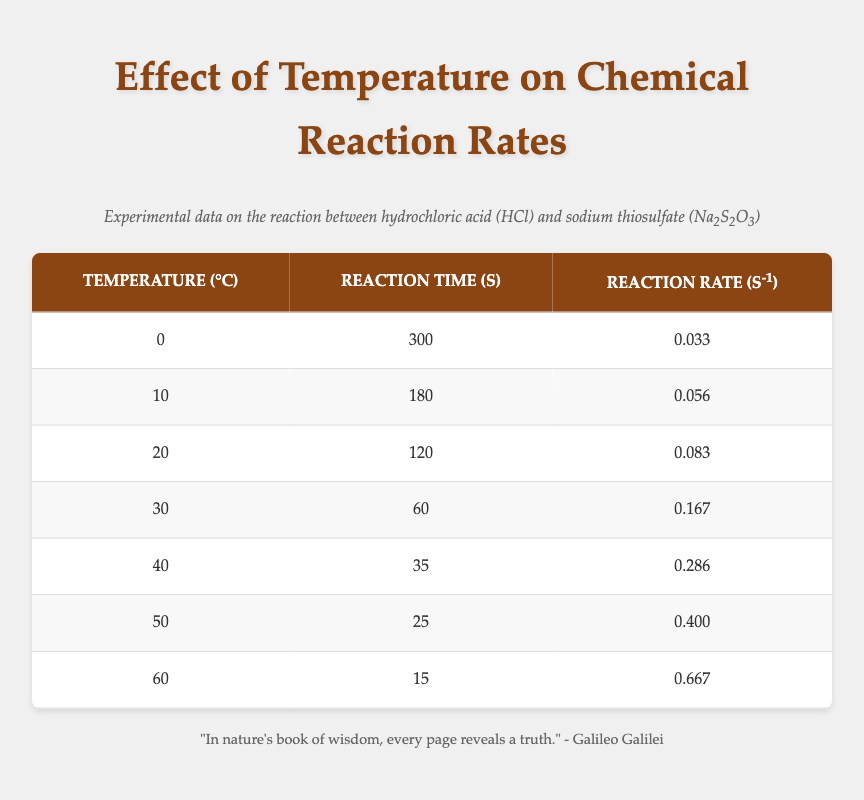What is the reaction time at 40 degrees Celsius? From the table, at 40 degrees Celsius, the reaction time is directly listed as 35 seconds.
Answer: 35 seconds What is the reaction rate at room temperature (20 degrees Celsius)? At 20 degrees Celsius, the reaction rate is provided in the table as 0.083 s^-1.
Answer: 0.083 s^-1 What is the difference in reaction time between 10 degrees Celsius and 30 degrees Celsius? The reaction time at 10 degrees Celsius is 180 seconds, and at 30 degrees Celsius, it is 60 seconds. The difference is 180 - 60 = 120 seconds.
Answer: 120 seconds Is the reaction rate higher at 50 degrees Celsius than at 40 degrees Celsius? Looking at the data, the reaction rate at 50 degrees Celsius is 0.400 s^-1, while at 40 degrees Celsius, it is 0.286 s^-1. Since 0.400 is greater than 0.286, the statement is true.
Answer: Yes What is the average reaction time for the experiments conducted? To find the average, sum all reaction times: (300 + 180 + 120 + 60 + 35 + 25 + 15) = 735 seconds. There are 7 data points, so the average reaction time is 735 / 7 = 105 seconds.
Answer: 105 seconds What happens to the reaction rate as temperature increases? Observing the table, it shows that the reaction rate increases as temperature rises: it starts at 0.033 at 0 degrees Celsius and reaches 0.667 at 60 degrees Celsius. This indicates a positive correlation between temperature and reaction rate.
Answer: Increases Which temperature resulted in the fastest reaction rate? Checking the table, the fastest reaction rate is at 60 degrees Celsius, where the rate is 0.667 s^-1.
Answer: 60 degrees Celsius How many seconds does the reaction take at 0 degrees Celsius? From the table, the reaction time at 0 degrees Celsius is clearly stated as 300 seconds.
Answer: 300 seconds What is the overall trend in reaction times from 0 to 60 degrees Celsius? Analyzing the data: reaction times decrease as the temperature increases; from 300 seconds at 0 degrees Celsius to 15 seconds at 60 degrees Celsius, indicating that higher temperatures facilitate faster reactions.
Answer: Decreases 